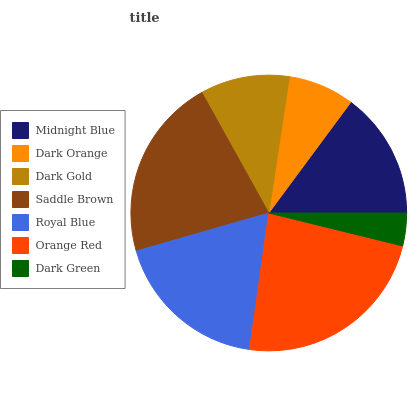Is Dark Green the minimum?
Answer yes or no. Yes. Is Orange Red the maximum?
Answer yes or no. Yes. Is Dark Orange the minimum?
Answer yes or no. No. Is Dark Orange the maximum?
Answer yes or no. No. Is Midnight Blue greater than Dark Orange?
Answer yes or no. Yes. Is Dark Orange less than Midnight Blue?
Answer yes or no. Yes. Is Dark Orange greater than Midnight Blue?
Answer yes or no. No. Is Midnight Blue less than Dark Orange?
Answer yes or no. No. Is Midnight Blue the high median?
Answer yes or no. Yes. Is Midnight Blue the low median?
Answer yes or no. Yes. Is Saddle Brown the high median?
Answer yes or no. No. Is Orange Red the low median?
Answer yes or no. No. 